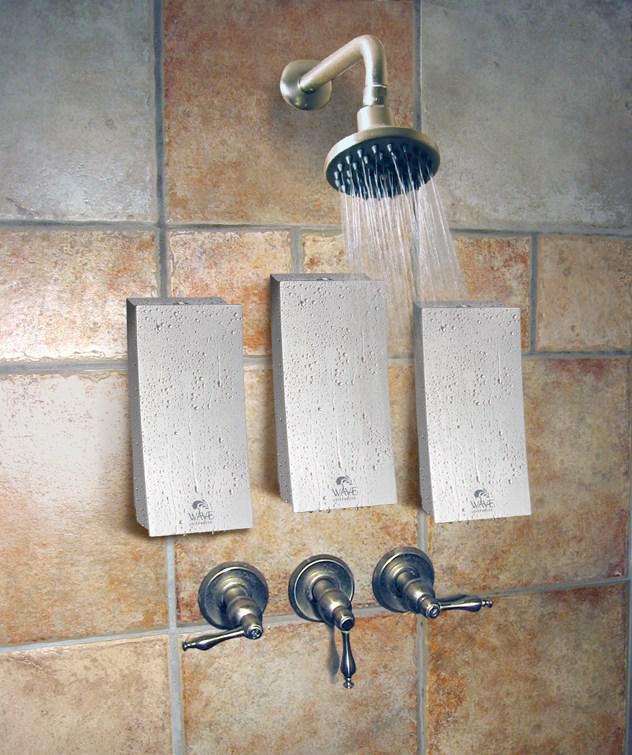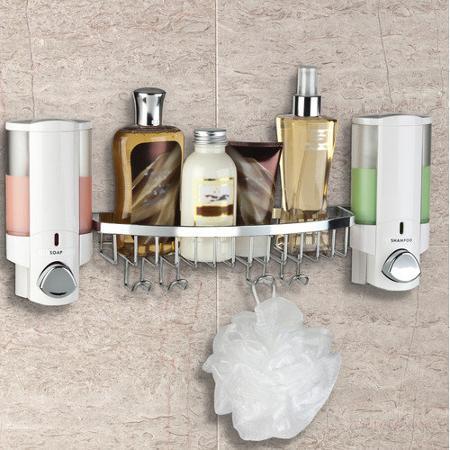The first image is the image on the left, the second image is the image on the right. Given the left and right images, does the statement "In one image there are two dispensers with a silver base." hold true? Answer yes or no. No. 